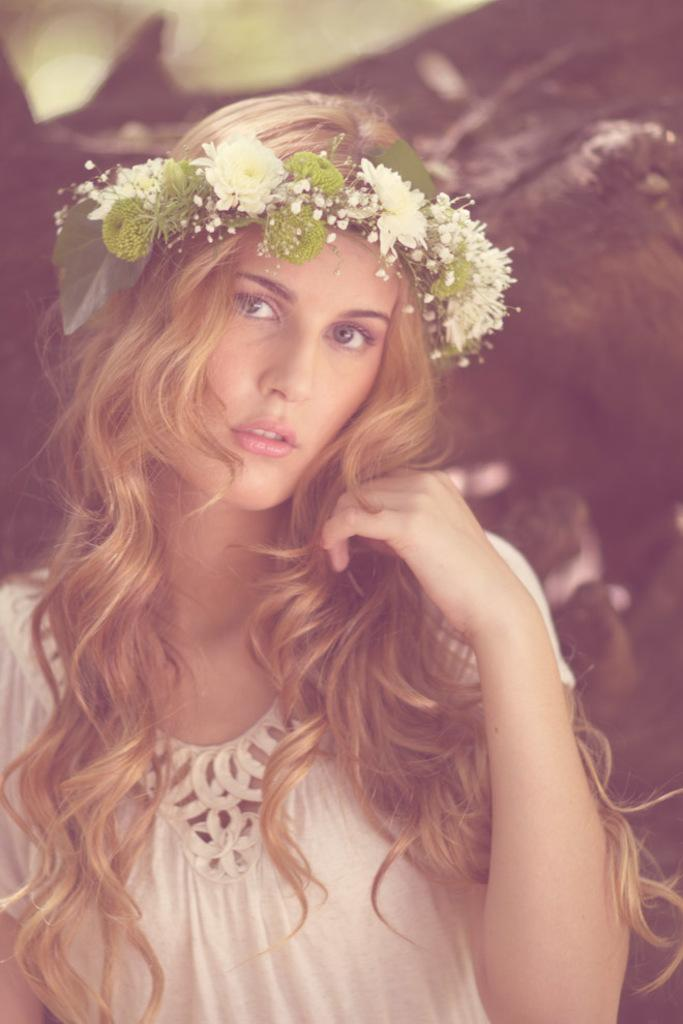Who is the main subject in the image? There is a woman in the image. What is the woman wearing? The woman is wearing a white dress and a headband. Can you describe the headband? The headband is cream and green in color. What can be seen in the background of the image? There are blurry objects in the background of the image. What type of idea is being expressed by the woman in the image? There is no indication in the image that the woman is expressing an idea, as the focus is on her clothing and accessories. 